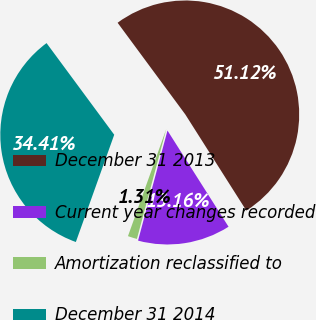Convert chart to OTSL. <chart><loc_0><loc_0><loc_500><loc_500><pie_chart><fcel>December 31 2013<fcel>Current year changes recorded<fcel>Amortization reclassified to<fcel>December 31 2014<nl><fcel>51.12%<fcel>13.16%<fcel>1.31%<fcel>34.41%<nl></chart> 